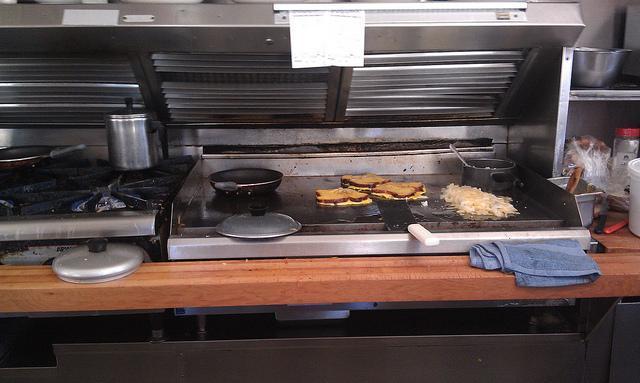How many sandwiches are on the grill?
Give a very brief answer. 3. 